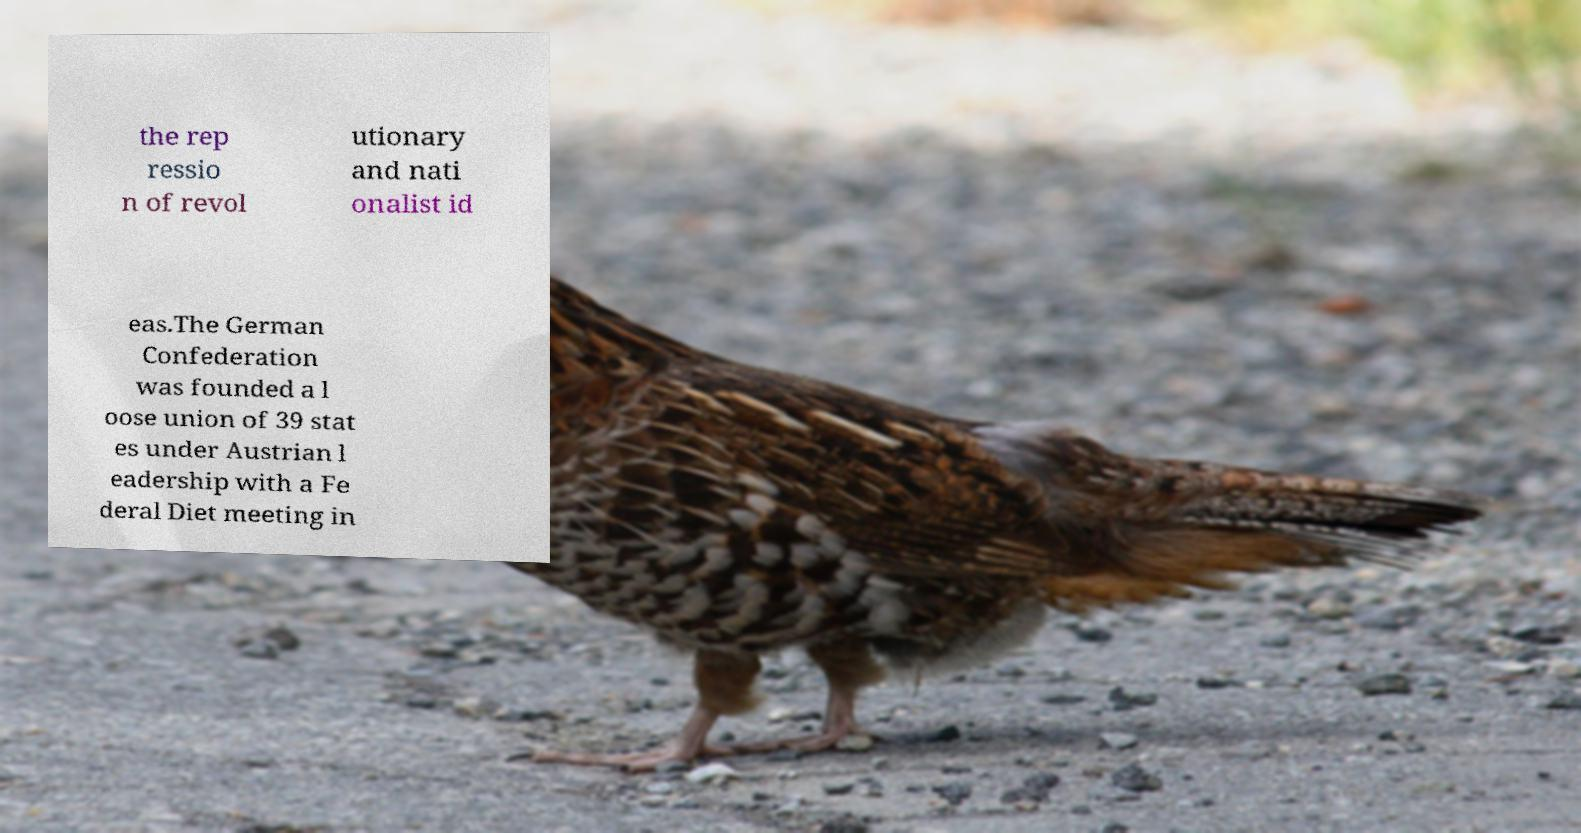I need the written content from this picture converted into text. Can you do that? the rep ressio n of revol utionary and nati onalist id eas.The German Confederation was founded a l oose union of 39 stat es under Austrian l eadership with a Fe deral Diet meeting in 